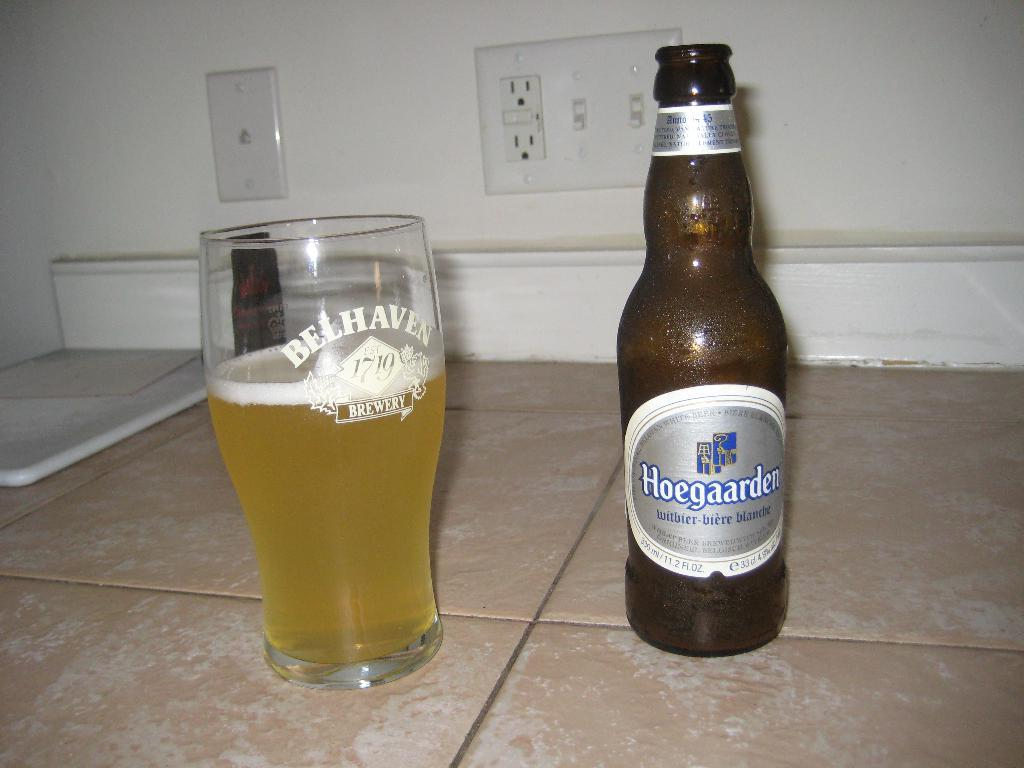<image>
Share a concise interpretation of the image provided. A Hoegaarden bottle is next to glass that is more than half full. 